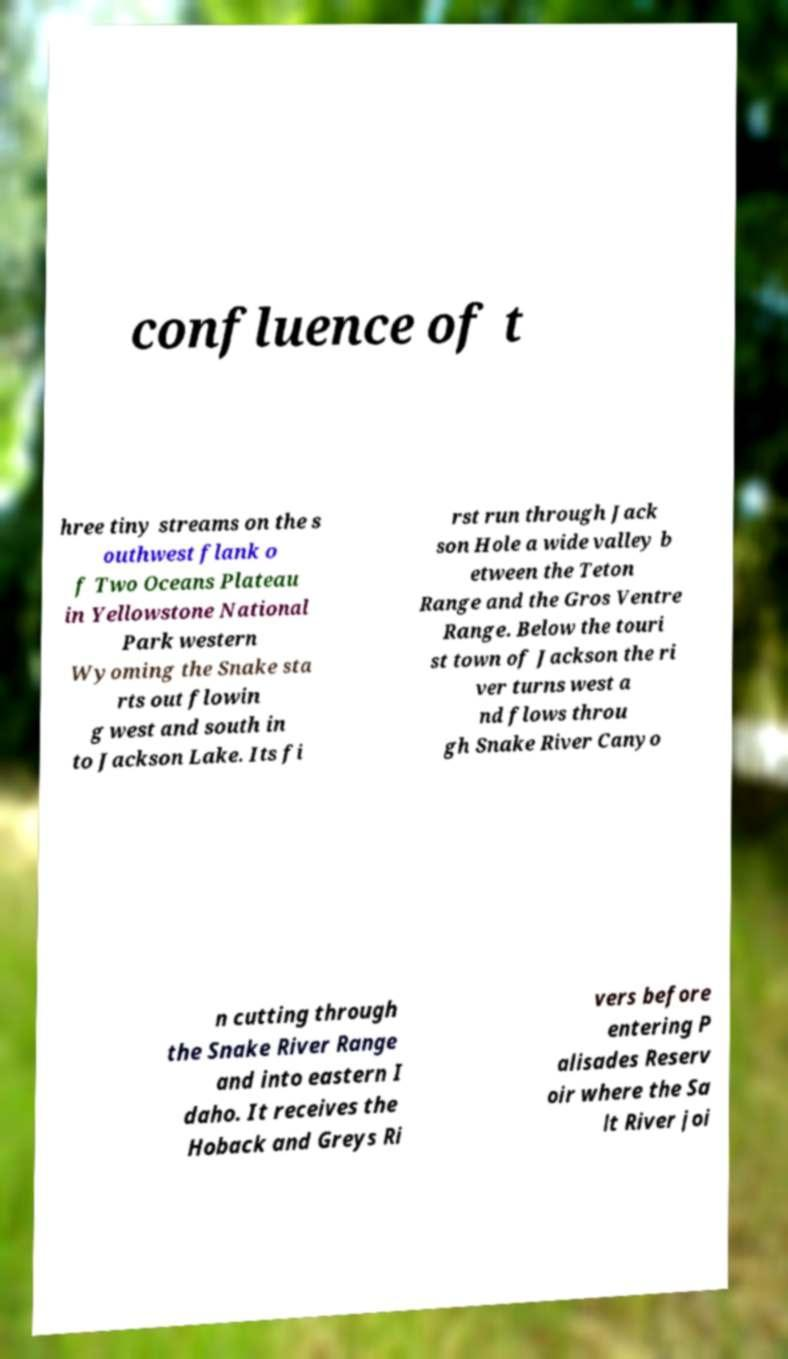I need the written content from this picture converted into text. Can you do that? confluence of t hree tiny streams on the s outhwest flank o f Two Oceans Plateau in Yellowstone National Park western Wyoming the Snake sta rts out flowin g west and south in to Jackson Lake. Its fi rst run through Jack son Hole a wide valley b etween the Teton Range and the Gros Ventre Range. Below the touri st town of Jackson the ri ver turns west a nd flows throu gh Snake River Canyo n cutting through the Snake River Range and into eastern I daho. It receives the Hoback and Greys Ri vers before entering P alisades Reserv oir where the Sa lt River joi 